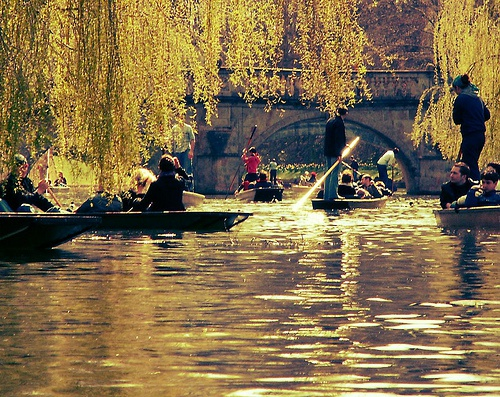Describe the objects in this image and their specific colors. I can see people in orange, black, navy, gray, and tan tones, boat in orange, black, navy, gray, and khaki tones, boat in orange, black, gray, navy, and darkblue tones, people in orange, black, navy, blue, and gray tones, and people in orange, black, gray, khaki, and navy tones in this image. 